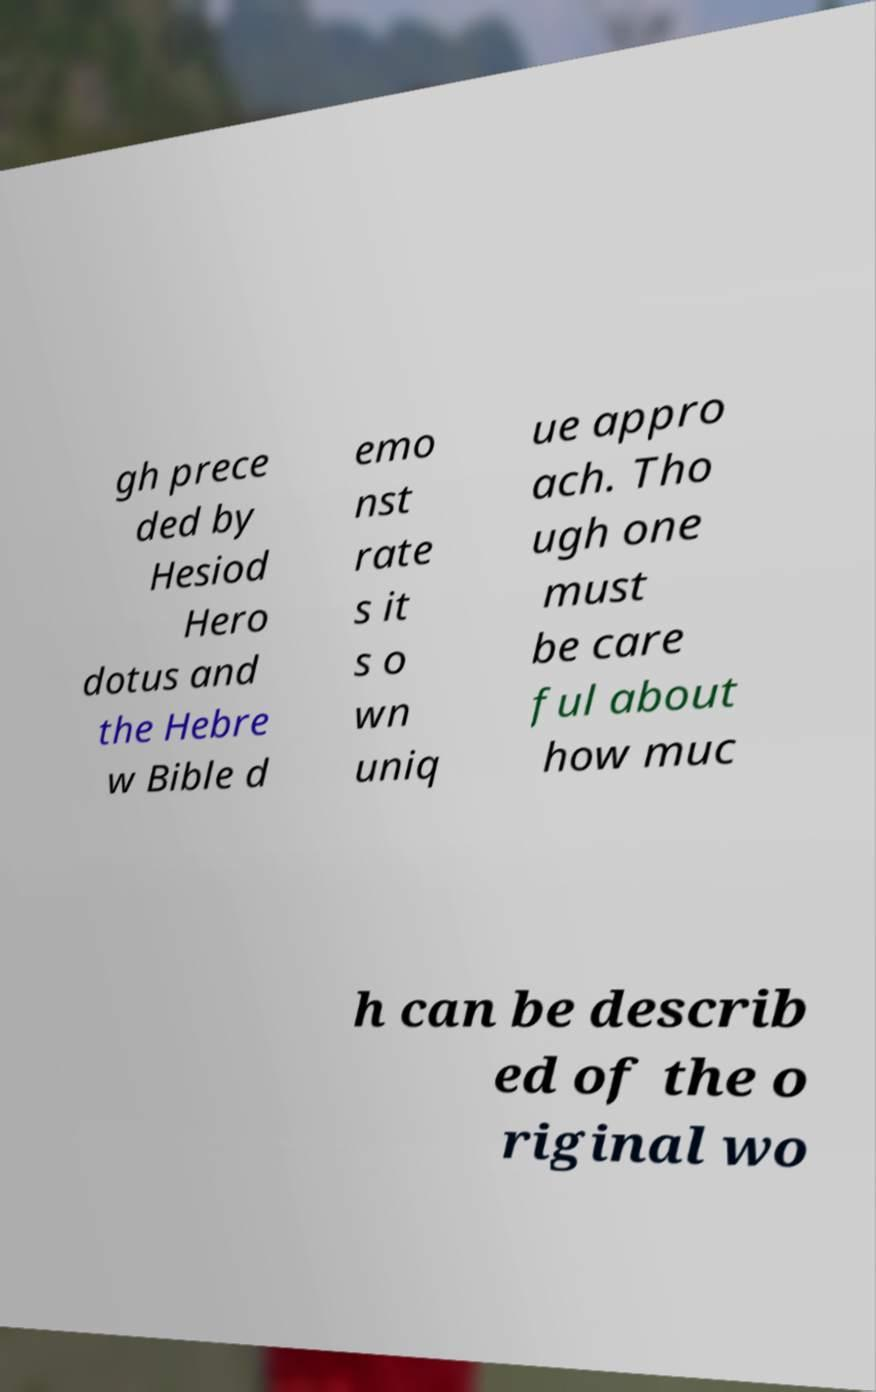Please read and relay the text visible in this image. What does it say? gh prece ded by Hesiod Hero dotus and the Hebre w Bible d emo nst rate s it s o wn uniq ue appro ach. Tho ugh one must be care ful about how muc h can be describ ed of the o riginal wo 